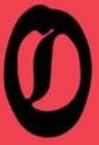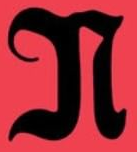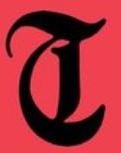What words are shown in these images in order, separated by a semicolon? O; N; T 